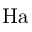<formula> <loc_0><loc_0><loc_500><loc_500>H a</formula> 